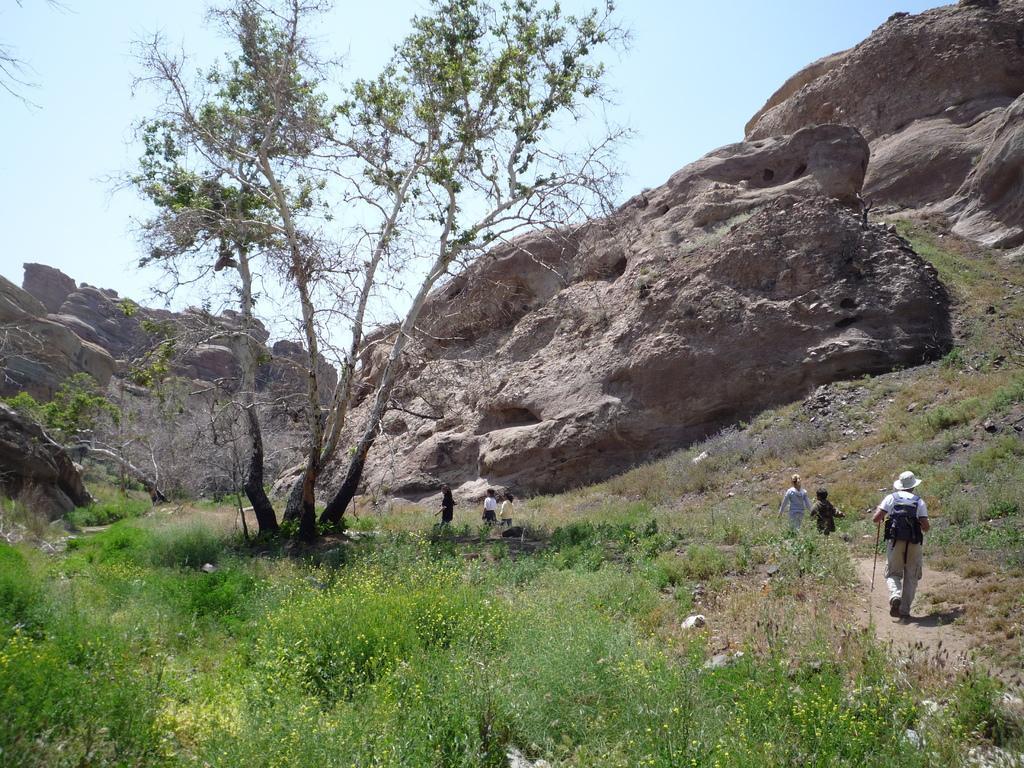Please provide a concise description of this image. In this image there are some people walking on the mud road beside them there is a rock mountain and at the left there are some plants and tree. 